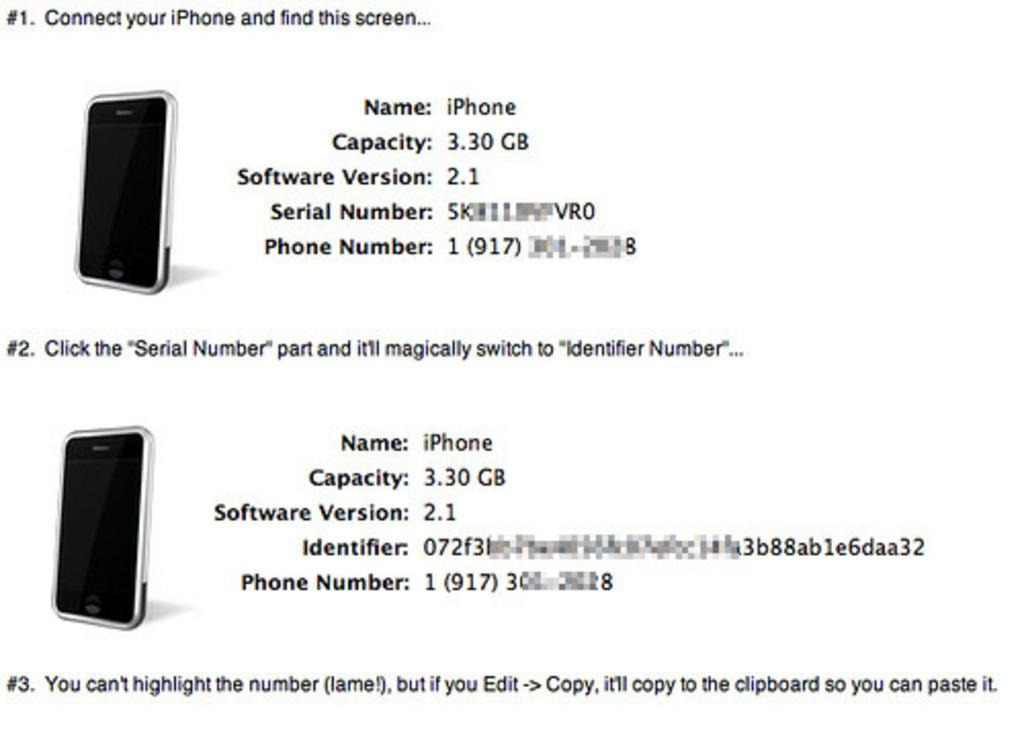<image>
Relay a brief, clear account of the picture shown. A screen detailing instructions on how to clone an iPhone. 